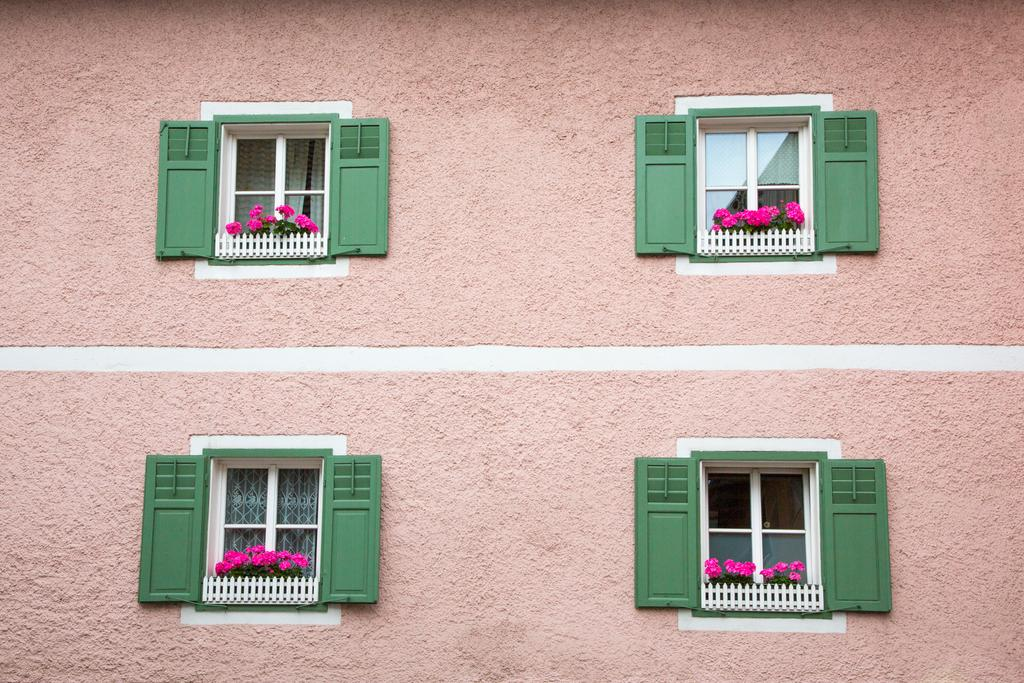What type of structure is visible in the image? There is a building in the image. How many windows are on the building? The building has four windows. What is located in front of the windows? Flower plants are present in front of the windows. What is the reaction of the island to the building in the image? There is no island present in the image, so it cannot react to the building. 